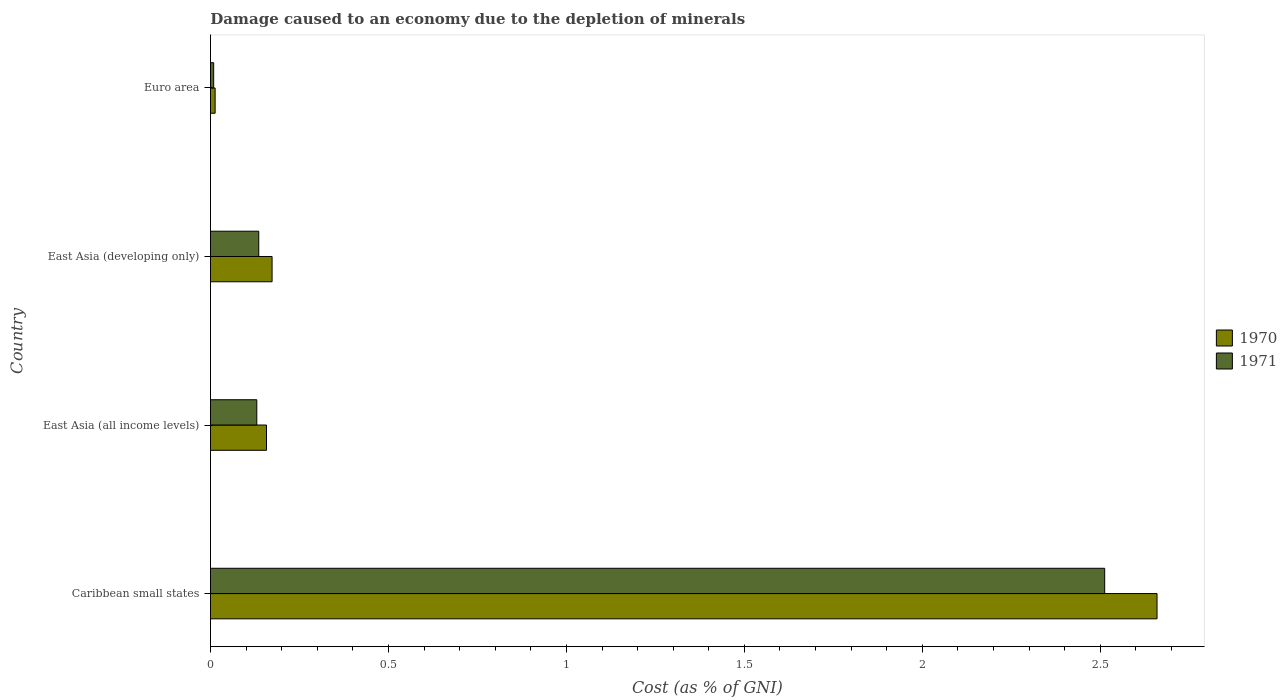How many different coloured bars are there?
Your response must be concise. 2. How many groups of bars are there?
Provide a succinct answer. 4. Are the number of bars per tick equal to the number of legend labels?
Ensure brevity in your answer.  Yes. Are the number of bars on each tick of the Y-axis equal?
Keep it short and to the point. Yes. How many bars are there on the 3rd tick from the top?
Provide a succinct answer. 2. How many bars are there on the 4th tick from the bottom?
Your answer should be compact. 2. In how many cases, is the number of bars for a given country not equal to the number of legend labels?
Offer a very short reply. 0. What is the cost of damage caused due to the depletion of minerals in 1970 in East Asia (all income levels)?
Ensure brevity in your answer.  0.16. Across all countries, what is the maximum cost of damage caused due to the depletion of minerals in 1970?
Make the answer very short. 2.66. Across all countries, what is the minimum cost of damage caused due to the depletion of minerals in 1971?
Offer a terse response. 0.01. In which country was the cost of damage caused due to the depletion of minerals in 1971 maximum?
Make the answer very short. Caribbean small states. What is the total cost of damage caused due to the depletion of minerals in 1971 in the graph?
Your response must be concise. 2.79. What is the difference between the cost of damage caused due to the depletion of minerals in 1970 in East Asia (developing only) and that in Euro area?
Offer a terse response. 0.16. What is the difference between the cost of damage caused due to the depletion of minerals in 1971 in Euro area and the cost of damage caused due to the depletion of minerals in 1970 in East Asia (all income levels)?
Keep it short and to the point. -0.15. What is the average cost of damage caused due to the depletion of minerals in 1971 per country?
Ensure brevity in your answer.  0.7. What is the difference between the cost of damage caused due to the depletion of minerals in 1971 and cost of damage caused due to the depletion of minerals in 1970 in East Asia (developing only)?
Ensure brevity in your answer.  -0.04. What is the ratio of the cost of damage caused due to the depletion of minerals in 1971 in East Asia (all income levels) to that in East Asia (developing only)?
Make the answer very short. 0.96. What is the difference between the highest and the second highest cost of damage caused due to the depletion of minerals in 1970?
Your response must be concise. 2.49. What is the difference between the highest and the lowest cost of damage caused due to the depletion of minerals in 1971?
Your response must be concise. 2.5. In how many countries, is the cost of damage caused due to the depletion of minerals in 1971 greater than the average cost of damage caused due to the depletion of minerals in 1971 taken over all countries?
Provide a succinct answer. 1. What does the 2nd bar from the top in Euro area represents?
Keep it short and to the point. 1970. What does the 1st bar from the bottom in Euro area represents?
Keep it short and to the point. 1970. How many bars are there?
Make the answer very short. 8. Are all the bars in the graph horizontal?
Your answer should be compact. Yes. How many countries are there in the graph?
Make the answer very short. 4. What is the difference between two consecutive major ticks on the X-axis?
Offer a terse response. 0.5. How many legend labels are there?
Provide a succinct answer. 2. How are the legend labels stacked?
Ensure brevity in your answer.  Vertical. What is the title of the graph?
Ensure brevity in your answer.  Damage caused to an economy due to the depletion of minerals. Does "2003" appear as one of the legend labels in the graph?
Ensure brevity in your answer.  No. What is the label or title of the X-axis?
Offer a terse response. Cost (as % of GNI). What is the label or title of the Y-axis?
Your response must be concise. Country. What is the Cost (as % of GNI) of 1970 in Caribbean small states?
Provide a short and direct response. 2.66. What is the Cost (as % of GNI) of 1971 in Caribbean small states?
Offer a terse response. 2.51. What is the Cost (as % of GNI) in 1970 in East Asia (all income levels)?
Keep it short and to the point. 0.16. What is the Cost (as % of GNI) of 1971 in East Asia (all income levels)?
Provide a succinct answer. 0.13. What is the Cost (as % of GNI) in 1970 in East Asia (developing only)?
Your answer should be compact. 0.17. What is the Cost (as % of GNI) in 1971 in East Asia (developing only)?
Ensure brevity in your answer.  0.14. What is the Cost (as % of GNI) in 1970 in Euro area?
Offer a very short reply. 0.01. What is the Cost (as % of GNI) in 1971 in Euro area?
Offer a terse response. 0.01. Across all countries, what is the maximum Cost (as % of GNI) in 1970?
Give a very brief answer. 2.66. Across all countries, what is the maximum Cost (as % of GNI) in 1971?
Your answer should be very brief. 2.51. Across all countries, what is the minimum Cost (as % of GNI) of 1970?
Make the answer very short. 0.01. Across all countries, what is the minimum Cost (as % of GNI) in 1971?
Ensure brevity in your answer.  0.01. What is the total Cost (as % of GNI) in 1970 in the graph?
Ensure brevity in your answer.  3. What is the total Cost (as % of GNI) in 1971 in the graph?
Your response must be concise. 2.79. What is the difference between the Cost (as % of GNI) of 1970 in Caribbean small states and that in East Asia (all income levels)?
Your response must be concise. 2.5. What is the difference between the Cost (as % of GNI) of 1971 in Caribbean small states and that in East Asia (all income levels)?
Offer a terse response. 2.38. What is the difference between the Cost (as % of GNI) in 1970 in Caribbean small states and that in East Asia (developing only)?
Keep it short and to the point. 2.49. What is the difference between the Cost (as % of GNI) of 1971 in Caribbean small states and that in East Asia (developing only)?
Offer a terse response. 2.38. What is the difference between the Cost (as % of GNI) in 1970 in Caribbean small states and that in Euro area?
Ensure brevity in your answer.  2.65. What is the difference between the Cost (as % of GNI) of 1971 in Caribbean small states and that in Euro area?
Provide a succinct answer. 2.5. What is the difference between the Cost (as % of GNI) in 1970 in East Asia (all income levels) and that in East Asia (developing only)?
Provide a short and direct response. -0.02. What is the difference between the Cost (as % of GNI) in 1971 in East Asia (all income levels) and that in East Asia (developing only)?
Offer a very short reply. -0.01. What is the difference between the Cost (as % of GNI) in 1970 in East Asia (all income levels) and that in Euro area?
Your response must be concise. 0.14. What is the difference between the Cost (as % of GNI) in 1971 in East Asia (all income levels) and that in Euro area?
Offer a very short reply. 0.12. What is the difference between the Cost (as % of GNI) of 1970 in East Asia (developing only) and that in Euro area?
Offer a terse response. 0.16. What is the difference between the Cost (as % of GNI) of 1971 in East Asia (developing only) and that in Euro area?
Keep it short and to the point. 0.13. What is the difference between the Cost (as % of GNI) of 1970 in Caribbean small states and the Cost (as % of GNI) of 1971 in East Asia (all income levels)?
Your answer should be compact. 2.53. What is the difference between the Cost (as % of GNI) of 1970 in Caribbean small states and the Cost (as % of GNI) of 1971 in East Asia (developing only)?
Your answer should be compact. 2.52. What is the difference between the Cost (as % of GNI) of 1970 in Caribbean small states and the Cost (as % of GNI) of 1971 in Euro area?
Offer a very short reply. 2.65. What is the difference between the Cost (as % of GNI) in 1970 in East Asia (all income levels) and the Cost (as % of GNI) in 1971 in East Asia (developing only)?
Give a very brief answer. 0.02. What is the difference between the Cost (as % of GNI) of 1970 in East Asia (all income levels) and the Cost (as % of GNI) of 1971 in Euro area?
Give a very brief answer. 0.15. What is the difference between the Cost (as % of GNI) of 1970 in East Asia (developing only) and the Cost (as % of GNI) of 1971 in Euro area?
Your answer should be compact. 0.16. What is the average Cost (as % of GNI) of 1970 per country?
Provide a succinct answer. 0.75. What is the average Cost (as % of GNI) of 1971 per country?
Offer a very short reply. 0.7. What is the difference between the Cost (as % of GNI) of 1970 and Cost (as % of GNI) of 1971 in Caribbean small states?
Give a very brief answer. 0.15. What is the difference between the Cost (as % of GNI) of 1970 and Cost (as % of GNI) of 1971 in East Asia (all income levels)?
Offer a very short reply. 0.03. What is the difference between the Cost (as % of GNI) in 1970 and Cost (as % of GNI) in 1971 in East Asia (developing only)?
Offer a terse response. 0.04. What is the difference between the Cost (as % of GNI) in 1970 and Cost (as % of GNI) in 1971 in Euro area?
Your answer should be very brief. 0. What is the ratio of the Cost (as % of GNI) of 1970 in Caribbean small states to that in East Asia (all income levels)?
Offer a terse response. 16.89. What is the ratio of the Cost (as % of GNI) of 1971 in Caribbean small states to that in East Asia (all income levels)?
Make the answer very short. 19.3. What is the ratio of the Cost (as % of GNI) in 1970 in Caribbean small states to that in East Asia (developing only)?
Provide a succinct answer. 15.36. What is the ratio of the Cost (as % of GNI) in 1971 in Caribbean small states to that in East Asia (developing only)?
Provide a short and direct response. 18.52. What is the ratio of the Cost (as % of GNI) in 1970 in Caribbean small states to that in Euro area?
Offer a terse response. 203.2. What is the ratio of the Cost (as % of GNI) of 1971 in Caribbean small states to that in Euro area?
Your answer should be compact. 279.03. What is the ratio of the Cost (as % of GNI) of 1970 in East Asia (all income levels) to that in East Asia (developing only)?
Provide a short and direct response. 0.91. What is the ratio of the Cost (as % of GNI) of 1971 in East Asia (all income levels) to that in East Asia (developing only)?
Your answer should be very brief. 0.96. What is the ratio of the Cost (as % of GNI) of 1970 in East Asia (all income levels) to that in Euro area?
Offer a very short reply. 12.03. What is the ratio of the Cost (as % of GNI) in 1971 in East Asia (all income levels) to that in Euro area?
Make the answer very short. 14.45. What is the ratio of the Cost (as % of GNI) in 1970 in East Asia (developing only) to that in Euro area?
Make the answer very short. 13.22. What is the ratio of the Cost (as % of GNI) of 1971 in East Asia (developing only) to that in Euro area?
Give a very brief answer. 15.07. What is the difference between the highest and the second highest Cost (as % of GNI) of 1970?
Your answer should be compact. 2.49. What is the difference between the highest and the second highest Cost (as % of GNI) of 1971?
Keep it short and to the point. 2.38. What is the difference between the highest and the lowest Cost (as % of GNI) of 1970?
Provide a short and direct response. 2.65. What is the difference between the highest and the lowest Cost (as % of GNI) of 1971?
Keep it short and to the point. 2.5. 